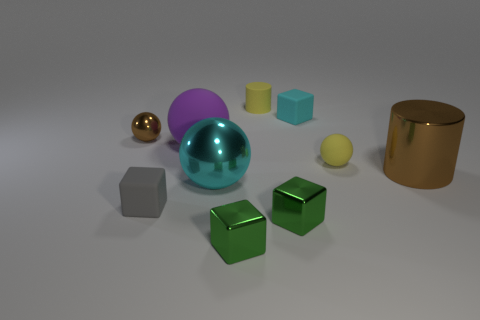Subtract all big cyan metallic balls. How many balls are left? 3 Subtract all yellow cylinders. How many cylinders are left? 1 Subtract all cyan balls. How many green blocks are left? 2 Subtract 1 cylinders. How many cylinders are left? 1 Subtract all large objects. Subtract all large yellow shiny spheres. How many objects are left? 7 Add 1 brown cylinders. How many brown cylinders are left? 2 Add 5 large purple objects. How many large purple objects exist? 6 Subtract 0 gray spheres. How many objects are left? 10 Subtract all cylinders. How many objects are left? 8 Subtract all blue cylinders. Subtract all brown balls. How many cylinders are left? 2 